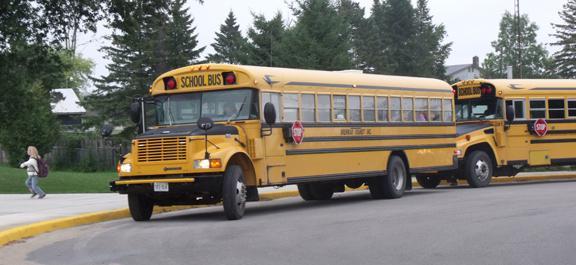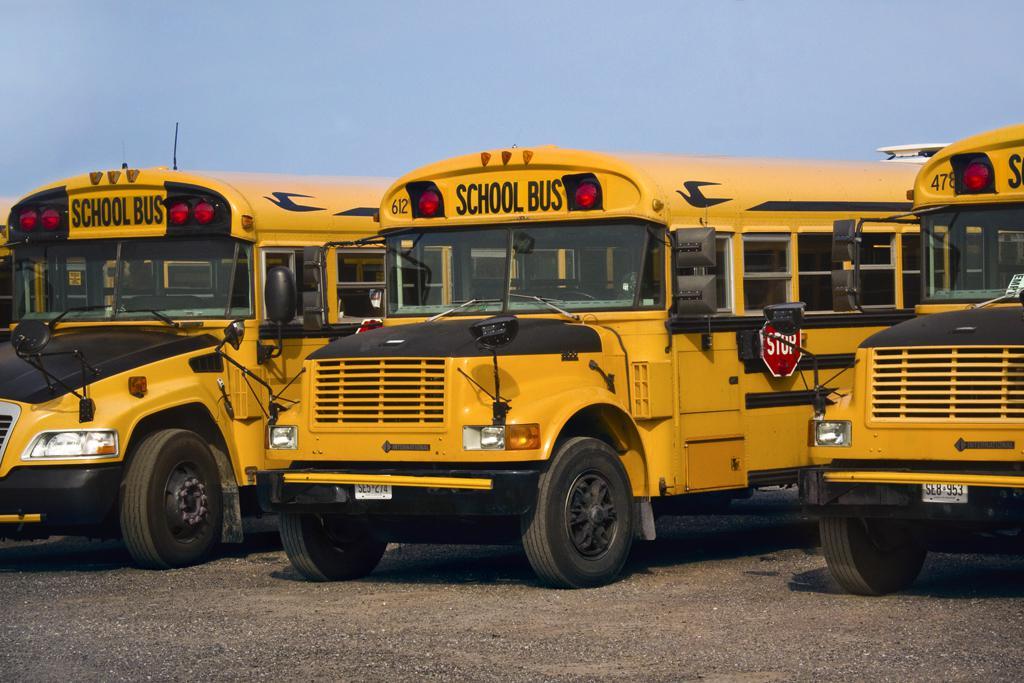The first image is the image on the left, the second image is the image on the right. Assess this claim about the two images: "The image on the right shows the back end of at least one bus.". Correct or not? Answer yes or no. No. The first image is the image on the left, the second image is the image on the right. Considering the images on both sides, is "An emergency is being dealt with right next to a school bus in one of the pictures." valid? Answer yes or no. No. 